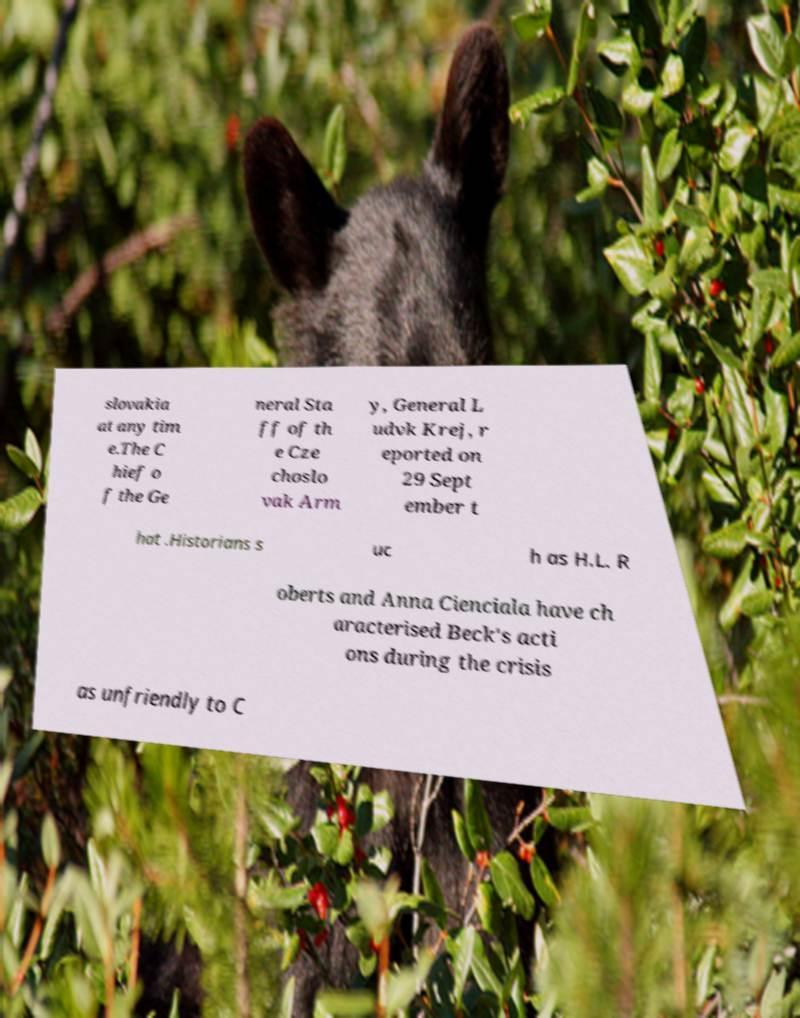For documentation purposes, I need the text within this image transcribed. Could you provide that? slovakia at any tim e.The C hief o f the Ge neral Sta ff of th e Cze choslo vak Arm y, General L udvk Krej, r eported on 29 Sept ember t hat .Historians s uc h as H.L. R oberts and Anna Cienciala have ch aracterised Beck's acti ons during the crisis as unfriendly to C 